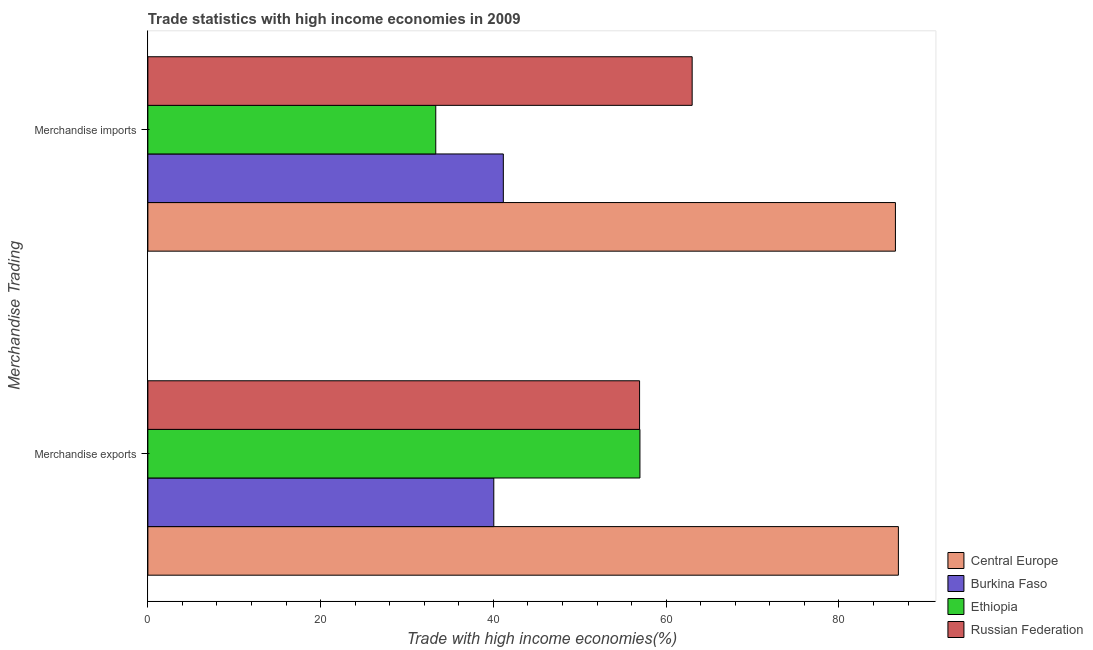How many different coloured bars are there?
Provide a short and direct response. 4. Are the number of bars per tick equal to the number of legend labels?
Keep it short and to the point. Yes. Are the number of bars on each tick of the Y-axis equal?
Ensure brevity in your answer.  Yes. How many bars are there on the 2nd tick from the top?
Give a very brief answer. 4. What is the merchandise imports in Burkina Faso?
Offer a very short reply. 41.15. Across all countries, what is the maximum merchandise imports?
Provide a succinct answer. 86.54. Across all countries, what is the minimum merchandise imports?
Your answer should be compact. 33.33. In which country was the merchandise exports maximum?
Offer a terse response. Central Europe. In which country was the merchandise exports minimum?
Offer a terse response. Burkina Faso. What is the total merchandise exports in the graph?
Make the answer very short. 240.82. What is the difference between the merchandise exports in Central Europe and that in Russian Federation?
Offer a terse response. 29.96. What is the difference between the merchandise imports in Burkina Faso and the merchandise exports in Central Europe?
Keep it short and to the point. -45.73. What is the average merchandise exports per country?
Ensure brevity in your answer.  60.21. What is the difference between the merchandise exports and merchandise imports in Central Europe?
Offer a very short reply. 0.34. In how many countries, is the merchandise exports greater than 24 %?
Offer a very short reply. 4. What is the ratio of the merchandise imports in Central Europe to that in Russian Federation?
Your response must be concise. 1.37. In how many countries, is the merchandise imports greater than the average merchandise imports taken over all countries?
Your answer should be compact. 2. What does the 3rd bar from the top in Merchandise exports represents?
Keep it short and to the point. Burkina Faso. What does the 1st bar from the bottom in Merchandise exports represents?
Your answer should be compact. Central Europe. What is the difference between two consecutive major ticks on the X-axis?
Your answer should be compact. 20. Are the values on the major ticks of X-axis written in scientific E-notation?
Your answer should be very brief. No. How many legend labels are there?
Ensure brevity in your answer.  4. How are the legend labels stacked?
Your answer should be very brief. Vertical. What is the title of the graph?
Give a very brief answer. Trade statistics with high income economies in 2009. Does "Kenya" appear as one of the legend labels in the graph?
Give a very brief answer. No. What is the label or title of the X-axis?
Offer a very short reply. Trade with high income economies(%). What is the label or title of the Y-axis?
Provide a succinct answer. Merchandise Trading. What is the Trade with high income economies(%) of Central Europe in Merchandise exports?
Keep it short and to the point. 86.89. What is the Trade with high income economies(%) of Burkina Faso in Merchandise exports?
Make the answer very short. 40.05. What is the Trade with high income economies(%) in Ethiopia in Merchandise exports?
Your answer should be compact. 56.96. What is the Trade with high income economies(%) in Russian Federation in Merchandise exports?
Your answer should be compact. 56.92. What is the Trade with high income economies(%) of Central Europe in Merchandise imports?
Keep it short and to the point. 86.54. What is the Trade with high income economies(%) of Burkina Faso in Merchandise imports?
Your answer should be compact. 41.15. What is the Trade with high income economies(%) in Ethiopia in Merchandise imports?
Keep it short and to the point. 33.33. What is the Trade with high income economies(%) of Russian Federation in Merchandise imports?
Give a very brief answer. 63.01. Across all Merchandise Trading, what is the maximum Trade with high income economies(%) in Central Europe?
Your answer should be very brief. 86.89. Across all Merchandise Trading, what is the maximum Trade with high income economies(%) of Burkina Faso?
Give a very brief answer. 41.15. Across all Merchandise Trading, what is the maximum Trade with high income economies(%) in Ethiopia?
Your answer should be very brief. 56.96. Across all Merchandise Trading, what is the maximum Trade with high income economies(%) in Russian Federation?
Give a very brief answer. 63.01. Across all Merchandise Trading, what is the minimum Trade with high income economies(%) of Central Europe?
Provide a succinct answer. 86.54. Across all Merchandise Trading, what is the minimum Trade with high income economies(%) in Burkina Faso?
Make the answer very short. 40.05. Across all Merchandise Trading, what is the minimum Trade with high income economies(%) of Ethiopia?
Keep it short and to the point. 33.33. Across all Merchandise Trading, what is the minimum Trade with high income economies(%) of Russian Federation?
Offer a very short reply. 56.92. What is the total Trade with high income economies(%) in Central Europe in the graph?
Your answer should be compact. 173.43. What is the total Trade with high income economies(%) of Burkina Faso in the graph?
Offer a terse response. 81.2. What is the total Trade with high income economies(%) of Ethiopia in the graph?
Offer a terse response. 90.29. What is the total Trade with high income economies(%) of Russian Federation in the graph?
Make the answer very short. 119.93. What is the difference between the Trade with high income economies(%) in Central Europe in Merchandise exports and that in Merchandise imports?
Keep it short and to the point. 0.34. What is the difference between the Trade with high income economies(%) of Burkina Faso in Merchandise exports and that in Merchandise imports?
Provide a succinct answer. -1.1. What is the difference between the Trade with high income economies(%) in Ethiopia in Merchandise exports and that in Merchandise imports?
Keep it short and to the point. 23.64. What is the difference between the Trade with high income economies(%) in Russian Federation in Merchandise exports and that in Merchandise imports?
Your answer should be very brief. -6.09. What is the difference between the Trade with high income economies(%) in Central Europe in Merchandise exports and the Trade with high income economies(%) in Burkina Faso in Merchandise imports?
Provide a succinct answer. 45.73. What is the difference between the Trade with high income economies(%) in Central Europe in Merchandise exports and the Trade with high income economies(%) in Ethiopia in Merchandise imports?
Keep it short and to the point. 53.56. What is the difference between the Trade with high income economies(%) of Central Europe in Merchandise exports and the Trade with high income economies(%) of Russian Federation in Merchandise imports?
Keep it short and to the point. 23.88. What is the difference between the Trade with high income economies(%) of Burkina Faso in Merchandise exports and the Trade with high income economies(%) of Ethiopia in Merchandise imports?
Offer a terse response. 6.72. What is the difference between the Trade with high income economies(%) of Burkina Faso in Merchandise exports and the Trade with high income economies(%) of Russian Federation in Merchandise imports?
Your answer should be compact. -22.96. What is the difference between the Trade with high income economies(%) in Ethiopia in Merchandise exports and the Trade with high income economies(%) in Russian Federation in Merchandise imports?
Your answer should be very brief. -6.05. What is the average Trade with high income economies(%) in Central Europe per Merchandise Trading?
Offer a very short reply. 86.71. What is the average Trade with high income economies(%) in Burkina Faso per Merchandise Trading?
Your response must be concise. 40.6. What is the average Trade with high income economies(%) in Ethiopia per Merchandise Trading?
Offer a very short reply. 45.15. What is the average Trade with high income economies(%) in Russian Federation per Merchandise Trading?
Make the answer very short. 59.97. What is the difference between the Trade with high income economies(%) of Central Europe and Trade with high income economies(%) of Burkina Faso in Merchandise exports?
Keep it short and to the point. 46.84. What is the difference between the Trade with high income economies(%) of Central Europe and Trade with high income economies(%) of Ethiopia in Merchandise exports?
Provide a short and direct response. 29.92. What is the difference between the Trade with high income economies(%) in Central Europe and Trade with high income economies(%) in Russian Federation in Merchandise exports?
Your answer should be compact. 29.96. What is the difference between the Trade with high income economies(%) of Burkina Faso and Trade with high income economies(%) of Ethiopia in Merchandise exports?
Provide a succinct answer. -16.92. What is the difference between the Trade with high income economies(%) of Burkina Faso and Trade with high income economies(%) of Russian Federation in Merchandise exports?
Your response must be concise. -16.88. What is the difference between the Trade with high income economies(%) in Ethiopia and Trade with high income economies(%) in Russian Federation in Merchandise exports?
Your answer should be very brief. 0.04. What is the difference between the Trade with high income economies(%) of Central Europe and Trade with high income economies(%) of Burkina Faso in Merchandise imports?
Your answer should be very brief. 45.39. What is the difference between the Trade with high income economies(%) in Central Europe and Trade with high income economies(%) in Ethiopia in Merchandise imports?
Keep it short and to the point. 53.21. What is the difference between the Trade with high income economies(%) of Central Europe and Trade with high income economies(%) of Russian Federation in Merchandise imports?
Give a very brief answer. 23.53. What is the difference between the Trade with high income economies(%) of Burkina Faso and Trade with high income economies(%) of Ethiopia in Merchandise imports?
Provide a succinct answer. 7.82. What is the difference between the Trade with high income economies(%) in Burkina Faso and Trade with high income economies(%) in Russian Federation in Merchandise imports?
Ensure brevity in your answer.  -21.86. What is the difference between the Trade with high income economies(%) of Ethiopia and Trade with high income economies(%) of Russian Federation in Merchandise imports?
Offer a terse response. -29.68. What is the ratio of the Trade with high income economies(%) in Central Europe in Merchandise exports to that in Merchandise imports?
Your answer should be very brief. 1. What is the ratio of the Trade with high income economies(%) in Burkina Faso in Merchandise exports to that in Merchandise imports?
Keep it short and to the point. 0.97. What is the ratio of the Trade with high income economies(%) of Ethiopia in Merchandise exports to that in Merchandise imports?
Your answer should be very brief. 1.71. What is the ratio of the Trade with high income economies(%) in Russian Federation in Merchandise exports to that in Merchandise imports?
Your response must be concise. 0.9. What is the difference between the highest and the second highest Trade with high income economies(%) in Central Europe?
Provide a succinct answer. 0.34. What is the difference between the highest and the second highest Trade with high income economies(%) in Burkina Faso?
Your response must be concise. 1.1. What is the difference between the highest and the second highest Trade with high income economies(%) in Ethiopia?
Offer a terse response. 23.64. What is the difference between the highest and the second highest Trade with high income economies(%) in Russian Federation?
Provide a succinct answer. 6.09. What is the difference between the highest and the lowest Trade with high income economies(%) in Central Europe?
Give a very brief answer. 0.34. What is the difference between the highest and the lowest Trade with high income economies(%) of Burkina Faso?
Provide a succinct answer. 1.1. What is the difference between the highest and the lowest Trade with high income economies(%) in Ethiopia?
Ensure brevity in your answer.  23.64. What is the difference between the highest and the lowest Trade with high income economies(%) of Russian Federation?
Provide a short and direct response. 6.09. 